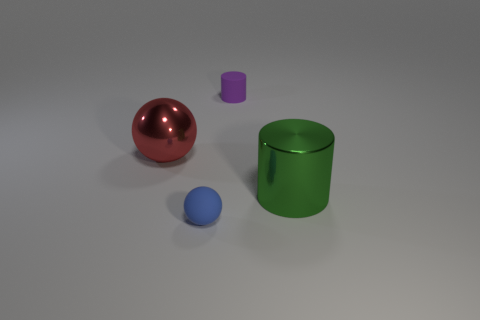Is the shape of the tiny purple thing the same as the rubber thing that is in front of the large green cylinder?
Keep it short and to the point. No. Is there any other thing that has the same color as the big metal sphere?
Your answer should be compact. No. Do the cylinder that is behind the large green shiny cylinder and the rubber sphere that is in front of the green cylinder have the same color?
Offer a very short reply. No. Are there any tiny blue shiny spheres?
Your answer should be very brief. No. Are there any tiny purple spheres made of the same material as the tiny purple cylinder?
Keep it short and to the point. No. Is there any other thing that has the same material as the tiny blue ball?
Provide a succinct answer. Yes. The small matte ball is what color?
Offer a terse response. Blue. The thing that is the same size as the green metal cylinder is what color?
Make the answer very short. Red. What number of metal objects are either purple objects or gray cubes?
Offer a terse response. 0. What number of small objects are both in front of the large cylinder and to the right of the small sphere?
Your answer should be very brief. 0. 